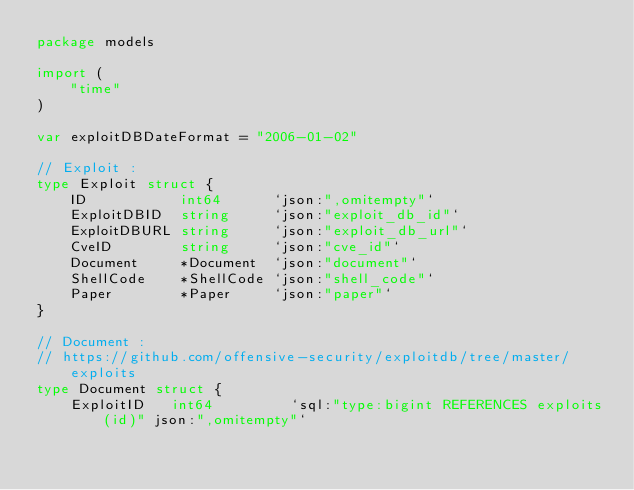Convert code to text. <code><loc_0><loc_0><loc_500><loc_500><_Go_>package models

import (
	"time"
)

var exploitDBDateFormat = "2006-01-02"

// Exploit :
type Exploit struct {
	ID           int64      `json:",omitempty"`
	ExploitDBID  string     `json:"exploit_db_id"`
	ExploitDBURL string     `json:"exploit_db_url"`
	CveID        string     `json:"cve_id"`
	Document     *Document  `json:"document"`
	ShellCode    *ShellCode `json:"shell_code"`
	Paper        *Paper     `json:"paper"`
}

// Document :
// https://github.com/offensive-security/exploitdb/tree/master/exploits
type Document struct {
	ExploitID   int64         `sql:"type:bigint REFERENCES exploits(id)" json:",omitempty"`</code> 